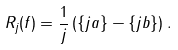<formula> <loc_0><loc_0><loc_500><loc_500>R _ { j } ( f ) = \frac { 1 } { j } \left ( \{ j a \} - \{ j b \} \right ) .</formula> 